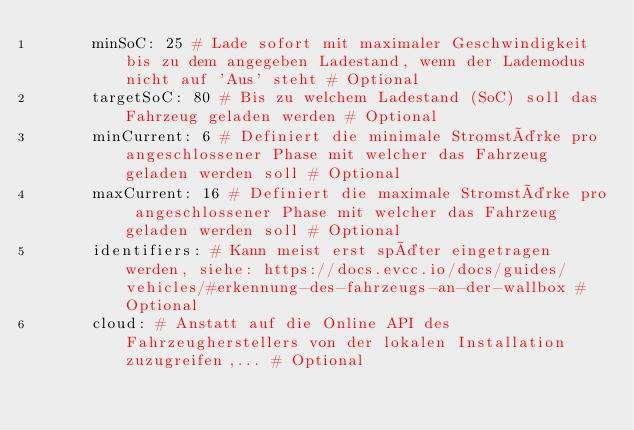Convert code to text. <code><loc_0><loc_0><loc_500><loc_500><_YAML_>      minSoC: 25 # Lade sofort mit maximaler Geschwindigkeit bis zu dem angegeben Ladestand, wenn der Lademodus nicht auf 'Aus' steht # Optional
      targetSoC: 80 # Bis zu welchem Ladestand (SoC) soll das Fahrzeug geladen werden # Optional
      minCurrent: 6 # Definiert die minimale Stromstärke pro angeschlossener Phase mit welcher das Fahrzeug geladen werden soll # Optional
      maxCurrent: 16 # Definiert die maximale Stromstärke pro angeschlossener Phase mit welcher das Fahrzeug geladen werden soll # Optional
      identifiers: # Kann meist erst später eingetragen werden, siehe: https://docs.evcc.io/docs/guides/vehicles/#erkennung-des-fahrzeugs-an-der-wallbox # Optional
      cloud: # Anstatt auf die Online API des Fahrzeugherstellers von der lokalen Installation zuzugreifen,... # Optional
</code> 